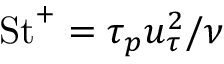Convert formula to latex. <formula><loc_0><loc_0><loc_500><loc_500>S t ^ { + } = \tau _ { p } u _ { \tau } ^ { 2 } / \nu</formula> 